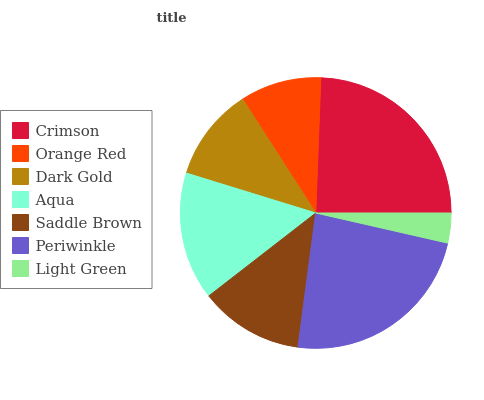Is Light Green the minimum?
Answer yes or no. Yes. Is Crimson the maximum?
Answer yes or no. Yes. Is Orange Red the minimum?
Answer yes or no. No. Is Orange Red the maximum?
Answer yes or no. No. Is Crimson greater than Orange Red?
Answer yes or no. Yes. Is Orange Red less than Crimson?
Answer yes or no. Yes. Is Orange Red greater than Crimson?
Answer yes or no. No. Is Crimson less than Orange Red?
Answer yes or no. No. Is Saddle Brown the high median?
Answer yes or no. Yes. Is Saddle Brown the low median?
Answer yes or no. Yes. Is Dark Gold the high median?
Answer yes or no. No. Is Dark Gold the low median?
Answer yes or no. No. 